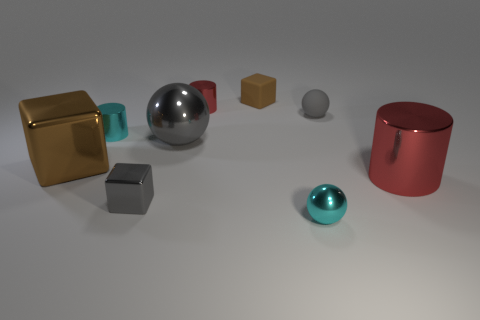What material is the gray object that is the same shape as the brown metal thing?
Give a very brief answer. Metal. How many brown objects are large cylinders or metal cylinders?
Make the answer very short. 0. What material is the tiny gray thing that is in front of the big metal cylinder?
Make the answer very short. Metal. Are there more small gray balls than red cylinders?
Offer a terse response. No. Is the shape of the red metallic thing that is to the right of the small gray rubber ball the same as  the large gray thing?
Your response must be concise. No. What number of metal objects are both behind the small metal sphere and right of the brown matte thing?
Ensure brevity in your answer.  1. What number of tiny red shiny things have the same shape as the brown shiny thing?
Keep it short and to the point. 0. What is the color of the tiny block that is behind the cylinder right of the tiny red shiny object?
Ensure brevity in your answer.  Brown. There is a large brown metallic object; is its shape the same as the cyan metal thing left of the large sphere?
Your answer should be compact. No. There is a tiny sphere that is behind the cyan metal object that is left of the small rubber object behind the small gray rubber object; what is its material?
Provide a short and direct response. Rubber. 